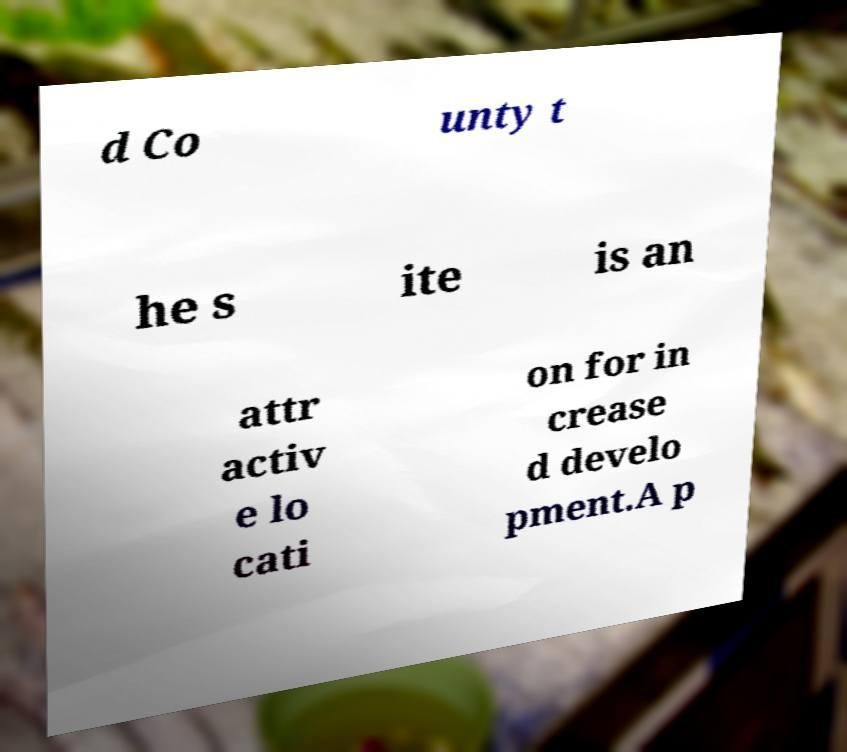I need the written content from this picture converted into text. Can you do that? d Co unty t he s ite is an attr activ e lo cati on for in crease d develo pment.A p 